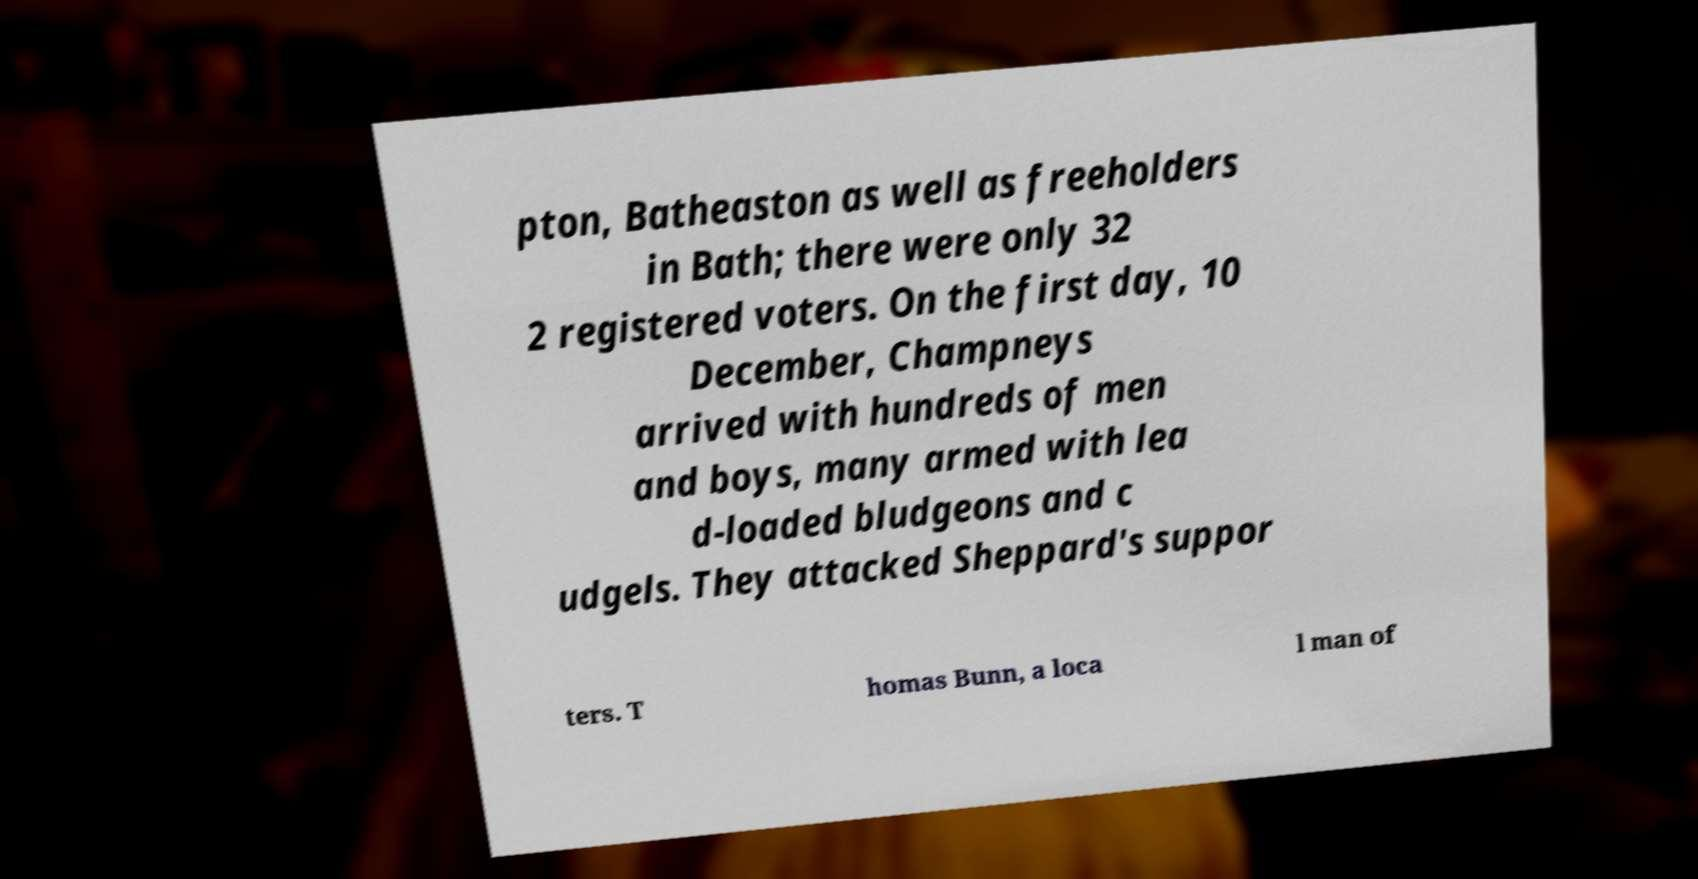Please read and relay the text visible in this image. What does it say? pton, Batheaston as well as freeholders in Bath; there were only 32 2 registered voters. On the first day, 10 December, Champneys arrived with hundreds of men and boys, many armed with lea d-loaded bludgeons and c udgels. They attacked Sheppard's suppor ters. T homas Bunn, a loca l man of 